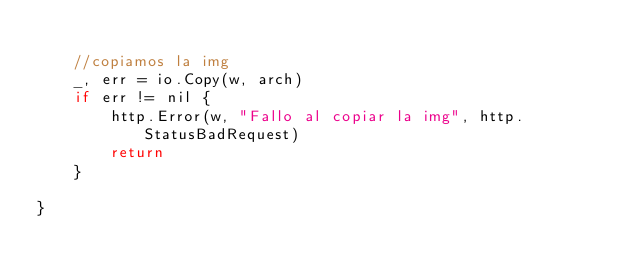Convert code to text. <code><loc_0><loc_0><loc_500><loc_500><_Go_>
	//copiamos la img
	_, err = io.Copy(w, arch)
	if err != nil {
		http.Error(w, "Fallo al copiar la img", http.StatusBadRequest)
		return
	}

}
</code> 